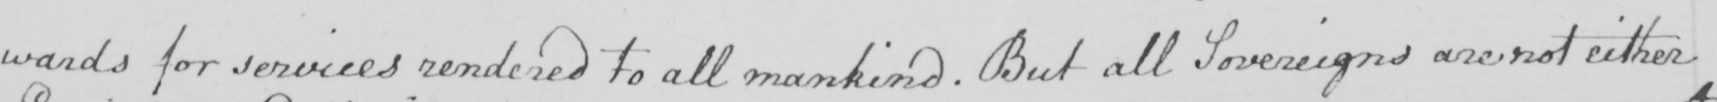What does this handwritten line say? wards for services rendered to all mankind . But all Sovereigns are not either 